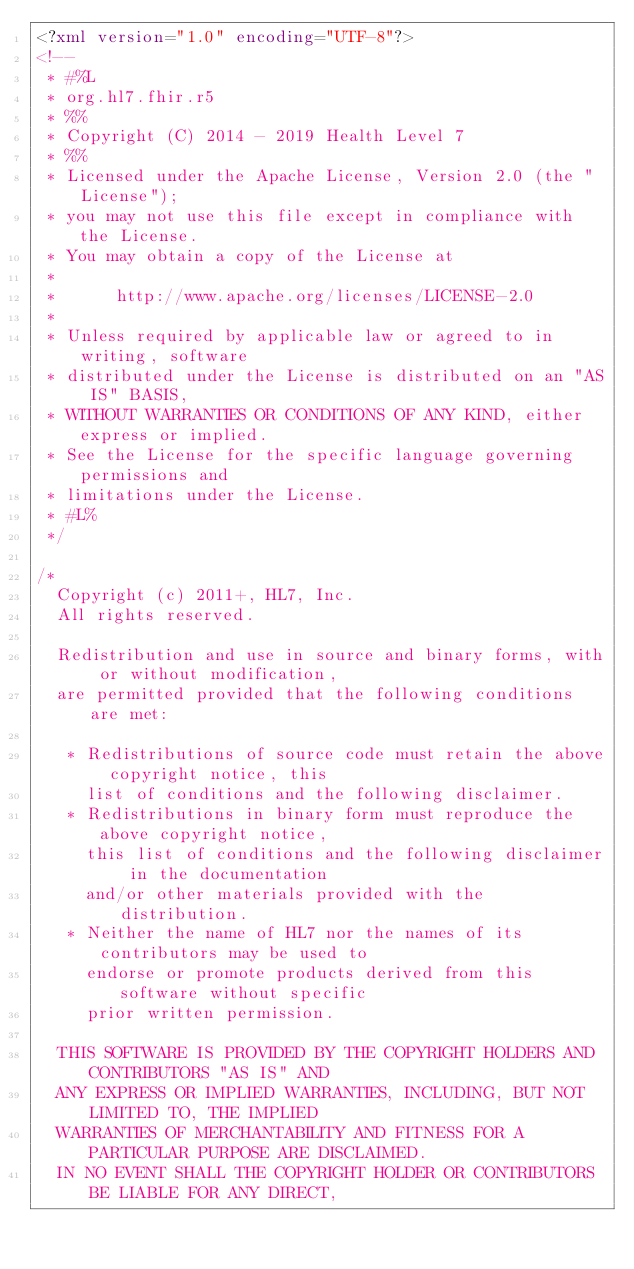<code> <loc_0><loc_0><loc_500><loc_500><_XML_><?xml version="1.0" encoding="UTF-8"?>
<!-- 
 * #%L
 * org.hl7.fhir.r5
 * %%
 * Copyright (C) 2014 - 2019 Health Level 7
 * %%
 * Licensed under the Apache License, Version 2.0 (the "License");
 * you may not use this file except in compliance with the License.
 * You may obtain a copy of the License at
 * 
 *      http://www.apache.org/licenses/LICENSE-2.0
 * 
 * Unless required by applicable law or agreed to in writing, software
 * distributed under the License is distributed on an "AS IS" BASIS,
 * WITHOUT WARRANTIES OR CONDITIONS OF ANY KIND, either express or implied.
 * See the License for the specific language governing permissions and
 * limitations under the License.
 * #L%
 */

/*
  Copyright (c) 2011+, HL7, Inc.
  All rights reserved.
  
  Redistribution and use in source and binary forms, with or without modification, 
  are permitted provided that the following conditions are met:
  
   * Redistributions of source code must retain the above copyright notice, this 
     list of conditions and the following disclaimer.
   * Redistributions in binary form must reproduce the above copyright notice, 
     this list of conditions and the following disclaimer in the documentation 
     and/or other materials provided with the distribution.
   * Neither the name of HL7 nor the names of its contributors may be used to 
     endorse or promote products derived from this software without specific 
     prior written permission.
  
  THIS SOFTWARE IS PROVIDED BY THE COPYRIGHT HOLDERS AND CONTRIBUTORS "AS IS" AND 
  ANY EXPRESS OR IMPLIED WARRANTIES, INCLUDING, BUT NOT LIMITED TO, THE IMPLIED 
  WARRANTIES OF MERCHANTABILITY AND FITNESS FOR A PARTICULAR PURPOSE ARE DISCLAIMED. 
  IN NO EVENT SHALL THE COPYRIGHT HOLDER OR CONTRIBUTORS BE LIABLE FOR ANY DIRECT, </code> 